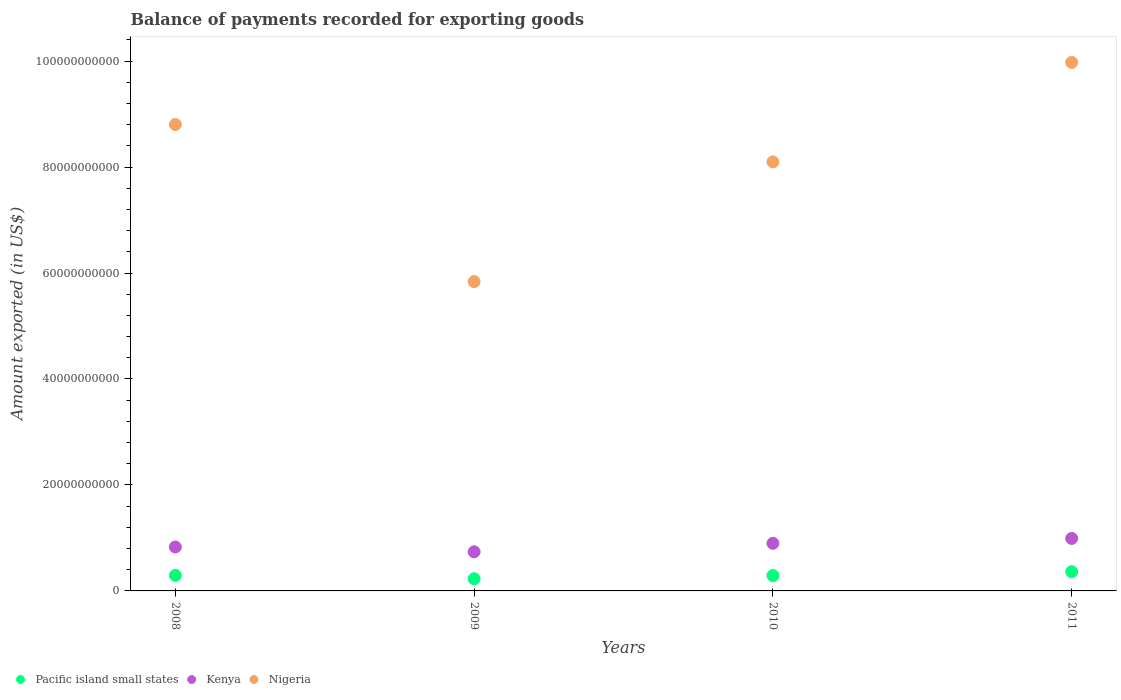How many different coloured dotlines are there?
Your answer should be very brief. 3. Is the number of dotlines equal to the number of legend labels?
Provide a short and direct response. Yes. What is the amount exported in Kenya in 2010?
Provide a succinct answer. 8.98e+09. Across all years, what is the maximum amount exported in Kenya?
Give a very brief answer. 9.91e+09. Across all years, what is the minimum amount exported in Kenya?
Provide a short and direct response. 7.39e+09. What is the total amount exported in Kenya in the graph?
Offer a terse response. 3.46e+1. What is the difference between the amount exported in Kenya in 2008 and that in 2011?
Provide a succinct answer. -1.62e+09. What is the difference between the amount exported in Pacific island small states in 2011 and the amount exported in Nigeria in 2010?
Provide a succinct answer. -7.74e+1. What is the average amount exported in Pacific island small states per year?
Keep it short and to the point. 2.94e+09. In the year 2011, what is the difference between the amount exported in Pacific island small states and amount exported in Kenya?
Give a very brief answer. -6.28e+09. In how many years, is the amount exported in Pacific island small states greater than 4000000000 US$?
Your answer should be compact. 0. What is the ratio of the amount exported in Kenya in 2008 to that in 2011?
Offer a terse response. 0.84. Is the amount exported in Pacific island small states in 2008 less than that in 2010?
Your answer should be compact. No. What is the difference between the highest and the second highest amount exported in Kenya?
Ensure brevity in your answer.  9.23e+08. What is the difference between the highest and the lowest amount exported in Pacific island small states?
Ensure brevity in your answer.  1.33e+09. Is it the case that in every year, the sum of the amount exported in Nigeria and amount exported in Kenya  is greater than the amount exported in Pacific island small states?
Keep it short and to the point. Yes. Is the amount exported in Kenya strictly greater than the amount exported in Pacific island small states over the years?
Your answer should be compact. Yes. How many dotlines are there?
Your response must be concise. 3. How many years are there in the graph?
Ensure brevity in your answer.  4. What is the difference between two consecutive major ticks on the Y-axis?
Ensure brevity in your answer.  2.00e+1. Are the values on the major ticks of Y-axis written in scientific E-notation?
Keep it short and to the point. No. Where does the legend appear in the graph?
Provide a succinct answer. Bottom left. How are the legend labels stacked?
Provide a short and direct response. Horizontal. What is the title of the graph?
Ensure brevity in your answer.  Balance of payments recorded for exporting goods. What is the label or title of the Y-axis?
Offer a very short reply. Amount exported (in US$). What is the Amount exported (in US$) in Pacific island small states in 2008?
Your response must be concise. 2.93e+09. What is the Amount exported (in US$) of Kenya in 2008?
Your answer should be very brief. 8.29e+09. What is the Amount exported (in US$) of Nigeria in 2008?
Provide a short and direct response. 8.80e+1. What is the Amount exported (in US$) of Pacific island small states in 2009?
Keep it short and to the point. 2.30e+09. What is the Amount exported (in US$) in Kenya in 2009?
Give a very brief answer. 7.39e+09. What is the Amount exported (in US$) in Nigeria in 2009?
Provide a succinct answer. 5.84e+1. What is the Amount exported (in US$) in Pacific island small states in 2010?
Ensure brevity in your answer.  2.89e+09. What is the Amount exported (in US$) in Kenya in 2010?
Give a very brief answer. 8.98e+09. What is the Amount exported (in US$) in Nigeria in 2010?
Your answer should be compact. 8.10e+1. What is the Amount exported (in US$) of Pacific island small states in 2011?
Your response must be concise. 3.62e+09. What is the Amount exported (in US$) of Kenya in 2011?
Provide a short and direct response. 9.91e+09. What is the Amount exported (in US$) of Nigeria in 2011?
Keep it short and to the point. 9.98e+1. Across all years, what is the maximum Amount exported (in US$) in Pacific island small states?
Your response must be concise. 3.62e+09. Across all years, what is the maximum Amount exported (in US$) of Kenya?
Your response must be concise. 9.91e+09. Across all years, what is the maximum Amount exported (in US$) of Nigeria?
Give a very brief answer. 9.98e+1. Across all years, what is the minimum Amount exported (in US$) of Pacific island small states?
Provide a succinct answer. 2.30e+09. Across all years, what is the minimum Amount exported (in US$) of Kenya?
Your answer should be very brief. 7.39e+09. Across all years, what is the minimum Amount exported (in US$) in Nigeria?
Ensure brevity in your answer.  5.84e+1. What is the total Amount exported (in US$) in Pacific island small states in the graph?
Keep it short and to the point. 1.17e+1. What is the total Amount exported (in US$) in Kenya in the graph?
Offer a terse response. 3.46e+1. What is the total Amount exported (in US$) in Nigeria in the graph?
Give a very brief answer. 3.27e+11. What is the difference between the Amount exported (in US$) in Pacific island small states in 2008 and that in 2009?
Provide a short and direct response. 6.35e+08. What is the difference between the Amount exported (in US$) in Kenya in 2008 and that in 2009?
Provide a succinct answer. 9.05e+08. What is the difference between the Amount exported (in US$) in Nigeria in 2008 and that in 2009?
Give a very brief answer. 2.97e+1. What is the difference between the Amount exported (in US$) of Pacific island small states in 2008 and that in 2010?
Offer a very short reply. 3.62e+07. What is the difference between the Amount exported (in US$) in Kenya in 2008 and that in 2010?
Make the answer very short. -6.93e+08. What is the difference between the Amount exported (in US$) in Nigeria in 2008 and that in 2010?
Offer a very short reply. 7.06e+09. What is the difference between the Amount exported (in US$) of Pacific island small states in 2008 and that in 2011?
Provide a short and direct response. -6.90e+08. What is the difference between the Amount exported (in US$) in Kenya in 2008 and that in 2011?
Offer a terse response. -1.62e+09. What is the difference between the Amount exported (in US$) in Nigeria in 2008 and that in 2011?
Your answer should be compact. -1.17e+1. What is the difference between the Amount exported (in US$) of Pacific island small states in 2009 and that in 2010?
Provide a succinct answer. -5.99e+08. What is the difference between the Amount exported (in US$) in Kenya in 2009 and that in 2010?
Offer a very short reply. -1.60e+09. What is the difference between the Amount exported (in US$) in Nigeria in 2009 and that in 2010?
Make the answer very short. -2.26e+1. What is the difference between the Amount exported (in US$) in Pacific island small states in 2009 and that in 2011?
Your answer should be compact. -1.33e+09. What is the difference between the Amount exported (in US$) of Kenya in 2009 and that in 2011?
Provide a short and direct response. -2.52e+09. What is the difference between the Amount exported (in US$) in Nigeria in 2009 and that in 2011?
Keep it short and to the point. -4.14e+1. What is the difference between the Amount exported (in US$) of Pacific island small states in 2010 and that in 2011?
Ensure brevity in your answer.  -7.27e+08. What is the difference between the Amount exported (in US$) in Kenya in 2010 and that in 2011?
Your answer should be very brief. -9.23e+08. What is the difference between the Amount exported (in US$) of Nigeria in 2010 and that in 2011?
Ensure brevity in your answer.  -1.88e+1. What is the difference between the Amount exported (in US$) in Pacific island small states in 2008 and the Amount exported (in US$) in Kenya in 2009?
Ensure brevity in your answer.  -4.45e+09. What is the difference between the Amount exported (in US$) in Pacific island small states in 2008 and the Amount exported (in US$) in Nigeria in 2009?
Give a very brief answer. -5.55e+1. What is the difference between the Amount exported (in US$) in Kenya in 2008 and the Amount exported (in US$) in Nigeria in 2009?
Your answer should be compact. -5.01e+1. What is the difference between the Amount exported (in US$) in Pacific island small states in 2008 and the Amount exported (in US$) in Kenya in 2010?
Your response must be concise. -6.05e+09. What is the difference between the Amount exported (in US$) in Pacific island small states in 2008 and the Amount exported (in US$) in Nigeria in 2010?
Give a very brief answer. -7.80e+1. What is the difference between the Amount exported (in US$) of Kenya in 2008 and the Amount exported (in US$) of Nigeria in 2010?
Keep it short and to the point. -7.27e+1. What is the difference between the Amount exported (in US$) in Pacific island small states in 2008 and the Amount exported (in US$) in Kenya in 2011?
Your answer should be compact. -6.98e+09. What is the difference between the Amount exported (in US$) of Pacific island small states in 2008 and the Amount exported (in US$) of Nigeria in 2011?
Provide a succinct answer. -9.68e+1. What is the difference between the Amount exported (in US$) of Kenya in 2008 and the Amount exported (in US$) of Nigeria in 2011?
Make the answer very short. -9.15e+1. What is the difference between the Amount exported (in US$) in Pacific island small states in 2009 and the Amount exported (in US$) in Kenya in 2010?
Ensure brevity in your answer.  -6.69e+09. What is the difference between the Amount exported (in US$) in Pacific island small states in 2009 and the Amount exported (in US$) in Nigeria in 2010?
Keep it short and to the point. -7.87e+1. What is the difference between the Amount exported (in US$) in Kenya in 2009 and the Amount exported (in US$) in Nigeria in 2010?
Keep it short and to the point. -7.36e+1. What is the difference between the Amount exported (in US$) of Pacific island small states in 2009 and the Amount exported (in US$) of Kenya in 2011?
Provide a succinct answer. -7.61e+09. What is the difference between the Amount exported (in US$) in Pacific island small states in 2009 and the Amount exported (in US$) in Nigeria in 2011?
Ensure brevity in your answer.  -9.75e+1. What is the difference between the Amount exported (in US$) in Kenya in 2009 and the Amount exported (in US$) in Nigeria in 2011?
Your response must be concise. -9.24e+1. What is the difference between the Amount exported (in US$) of Pacific island small states in 2010 and the Amount exported (in US$) of Kenya in 2011?
Ensure brevity in your answer.  -7.01e+09. What is the difference between the Amount exported (in US$) in Pacific island small states in 2010 and the Amount exported (in US$) in Nigeria in 2011?
Offer a very short reply. -9.69e+1. What is the difference between the Amount exported (in US$) of Kenya in 2010 and the Amount exported (in US$) of Nigeria in 2011?
Provide a short and direct response. -9.08e+1. What is the average Amount exported (in US$) in Pacific island small states per year?
Provide a succinct answer. 2.94e+09. What is the average Amount exported (in US$) in Kenya per year?
Ensure brevity in your answer.  8.64e+09. What is the average Amount exported (in US$) in Nigeria per year?
Offer a very short reply. 8.18e+1. In the year 2008, what is the difference between the Amount exported (in US$) in Pacific island small states and Amount exported (in US$) in Kenya?
Provide a succinct answer. -5.36e+09. In the year 2008, what is the difference between the Amount exported (in US$) of Pacific island small states and Amount exported (in US$) of Nigeria?
Your answer should be very brief. -8.51e+1. In the year 2008, what is the difference between the Amount exported (in US$) in Kenya and Amount exported (in US$) in Nigeria?
Give a very brief answer. -7.97e+1. In the year 2009, what is the difference between the Amount exported (in US$) in Pacific island small states and Amount exported (in US$) in Kenya?
Your answer should be compact. -5.09e+09. In the year 2009, what is the difference between the Amount exported (in US$) of Pacific island small states and Amount exported (in US$) of Nigeria?
Provide a succinct answer. -5.61e+1. In the year 2009, what is the difference between the Amount exported (in US$) in Kenya and Amount exported (in US$) in Nigeria?
Offer a very short reply. -5.10e+1. In the year 2010, what is the difference between the Amount exported (in US$) in Pacific island small states and Amount exported (in US$) in Kenya?
Your response must be concise. -6.09e+09. In the year 2010, what is the difference between the Amount exported (in US$) in Pacific island small states and Amount exported (in US$) in Nigeria?
Provide a succinct answer. -7.81e+1. In the year 2010, what is the difference between the Amount exported (in US$) in Kenya and Amount exported (in US$) in Nigeria?
Your answer should be very brief. -7.20e+1. In the year 2011, what is the difference between the Amount exported (in US$) in Pacific island small states and Amount exported (in US$) in Kenya?
Give a very brief answer. -6.28e+09. In the year 2011, what is the difference between the Amount exported (in US$) of Pacific island small states and Amount exported (in US$) of Nigeria?
Your answer should be compact. -9.61e+1. In the year 2011, what is the difference between the Amount exported (in US$) in Kenya and Amount exported (in US$) in Nigeria?
Offer a very short reply. -8.98e+1. What is the ratio of the Amount exported (in US$) in Pacific island small states in 2008 to that in 2009?
Keep it short and to the point. 1.28. What is the ratio of the Amount exported (in US$) of Kenya in 2008 to that in 2009?
Give a very brief answer. 1.12. What is the ratio of the Amount exported (in US$) of Nigeria in 2008 to that in 2009?
Give a very brief answer. 1.51. What is the ratio of the Amount exported (in US$) of Pacific island small states in 2008 to that in 2010?
Your answer should be very brief. 1.01. What is the ratio of the Amount exported (in US$) of Kenya in 2008 to that in 2010?
Ensure brevity in your answer.  0.92. What is the ratio of the Amount exported (in US$) of Nigeria in 2008 to that in 2010?
Offer a terse response. 1.09. What is the ratio of the Amount exported (in US$) in Pacific island small states in 2008 to that in 2011?
Give a very brief answer. 0.81. What is the ratio of the Amount exported (in US$) in Kenya in 2008 to that in 2011?
Make the answer very short. 0.84. What is the ratio of the Amount exported (in US$) of Nigeria in 2008 to that in 2011?
Provide a short and direct response. 0.88. What is the ratio of the Amount exported (in US$) of Pacific island small states in 2009 to that in 2010?
Provide a succinct answer. 0.79. What is the ratio of the Amount exported (in US$) of Kenya in 2009 to that in 2010?
Make the answer very short. 0.82. What is the ratio of the Amount exported (in US$) in Nigeria in 2009 to that in 2010?
Your answer should be compact. 0.72. What is the ratio of the Amount exported (in US$) of Pacific island small states in 2009 to that in 2011?
Provide a short and direct response. 0.63. What is the ratio of the Amount exported (in US$) of Kenya in 2009 to that in 2011?
Give a very brief answer. 0.75. What is the ratio of the Amount exported (in US$) in Nigeria in 2009 to that in 2011?
Provide a short and direct response. 0.59. What is the ratio of the Amount exported (in US$) of Pacific island small states in 2010 to that in 2011?
Provide a succinct answer. 0.8. What is the ratio of the Amount exported (in US$) in Kenya in 2010 to that in 2011?
Make the answer very short. 0.91. What is the ratio of the Amount exported (in US$) in Nigeria in 2010 to that in 2011?
Ensure brevity in your answer.  0.81. What is the difference between the highest and the second highest Amount exported (in US$) of Pacific island small states?
Offer a terse response. 6.90e+08. What is the difference between the highest and the second highest Amount exported (in US$) of Kenya?
Offer a very short reply. 9.23e+08. What is the difference between the highest and the second highest Amount exported (in US$) in Nigeria?
Your response must be concise. 1.17e+1. What is the difference between the highest and the lowest Amount exported (in US$) in Pacific island small states?
Provide a short and direct response. 1.33e+09. What is the difference between the highest and the lowest Amount exported (in US$) of Kenya?
Give a very brief answer. 2.52e+09. What is the difference between the highest and the lowest Amount exported (in US$) of Nigeria?
Your answer should be very brief. 4.14e+1. 